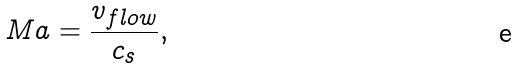Convert formula to latex. <formula><loc_0><loc_0><loc_500><loc_500>M a = \frac { v _ { f l o w } } { c _ { s } } ,</formula> 